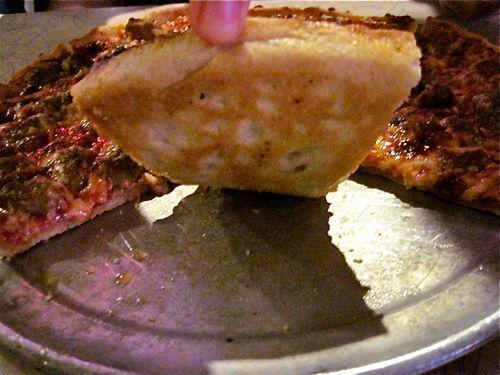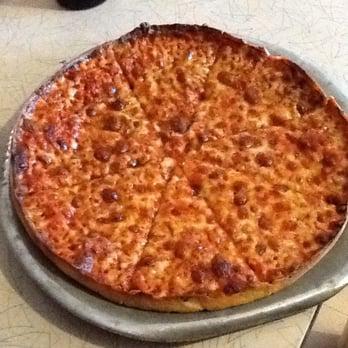The first image is the image on the left, the second image is the image on the right. Considering the images on both sides, is "The left image shows a round sliced pizza in a round pan with an empty space where two slices would fit, and does not show any other pans of pizza." valid? Answer yes or no. Yes. The first image is the image on the left, the second image is the image on the right. For the images shown, is this caption "All of the pizzas are whole without any pieces missing." true? Answer yes or no. No. 